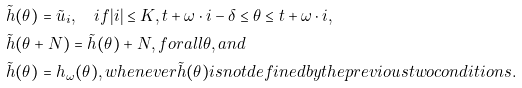<formula> <loc_0><loc_0><loc_500><loc_500>& \tilde { h } ( \theta ) = \tilde { u } _ { i } , \quad i f | i | \leq K , t + \omega \cdot i - \delta \leq \theta \leq t + \omega \cdot i , \\ & \tilde { h } ( \theta + N ) = \tilde { h } ( \theta ) + N , f o r a l l \theta , a n d \\ & \tilde { h } ( \theta ) = h _ { \omega } ( \theta ) , w h e n e v e r \tilde { h } ( \theta ) i s n o t d e f i n e d b y t h e p r e v i o u s t w o c o n d i t i o n s .</formula> 